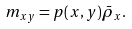<formula> <loc_0><loc_0><loc_500><loc_500>m _ { x y } = p ( x , y ) \bar { \rho } _ { x } .</formula> 